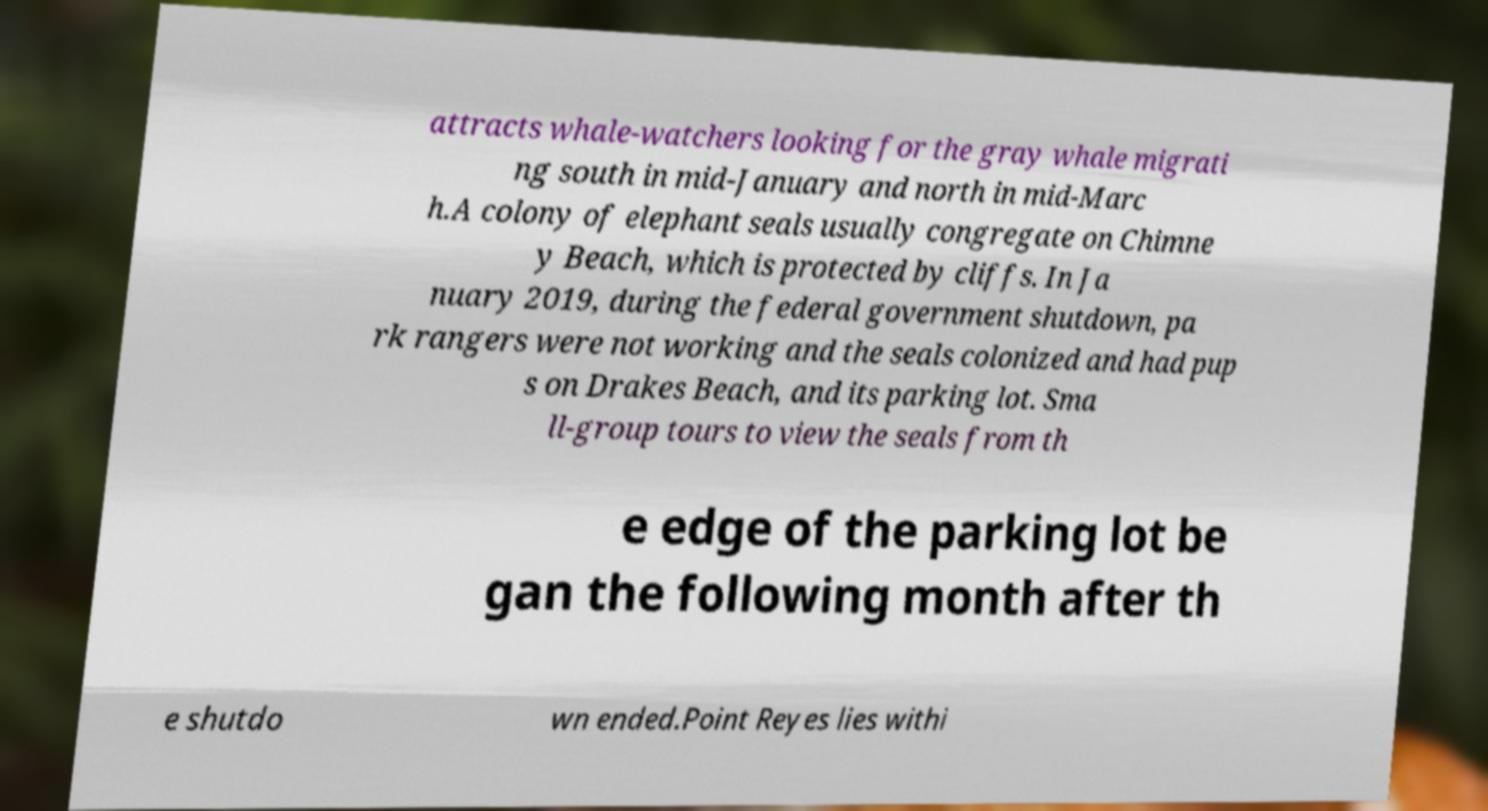Could you assist in decoding the text presented in this image and type it out clearly? attracts whale-watchers looking for the gray whale migrati ng south in mid-January and north in mid-Marc h.A colony of elephant seals usually congregate on Chimne y Beach, which is protected by cliffs. In Ja nuary 2019, during the federal government shutdown, pa rk rangers were not working and the seals colonized and had pup s on Drakes Beach, and its parking lot. Sma ll-group tours to view the seals from th e edge of the parking lot be gan the following month after th e shutdo wn ended.Point Reyes lies withi 